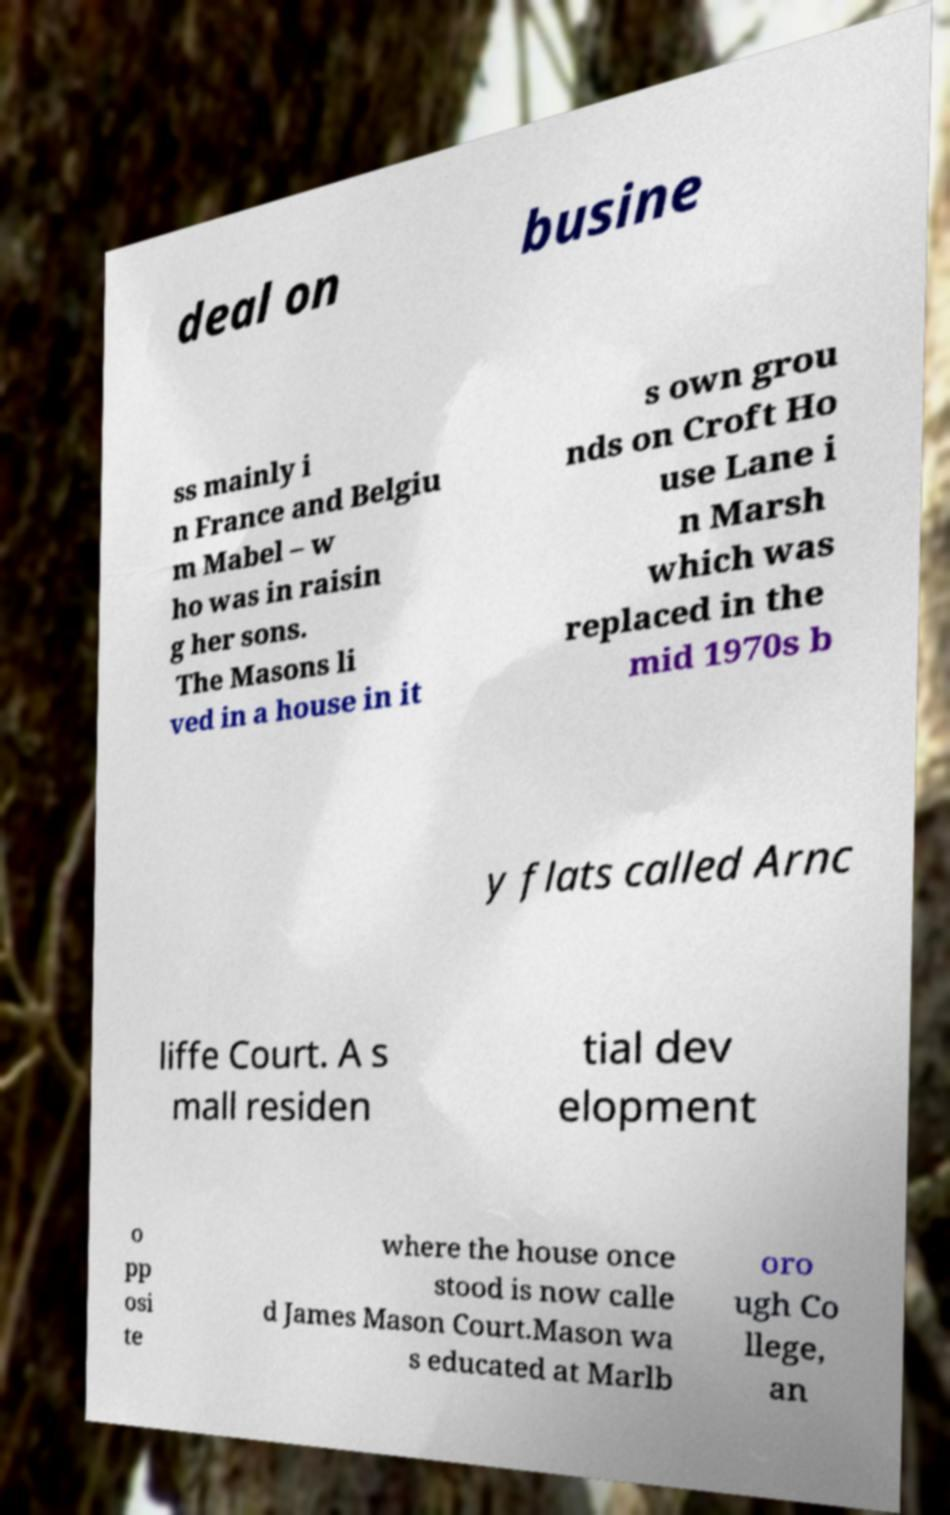For documentation purposes, I need the text within this image transcribed. Could you provide that? deal on busine ss mainly i n France and Belgiu m Mabel – w ho was in raisin g her sons. The Masons li ved in a house in it s own grou nds on Croft Ho use Lane i n Marsh which was replaced in the mid 1970s b y flats called Arnc liffe Court. A s mall residen tial dev elopment o pp osi te where the house once stood is now calle d James Mason Court.Mason wa s educated at Marlb oro ugh Co llege, an 